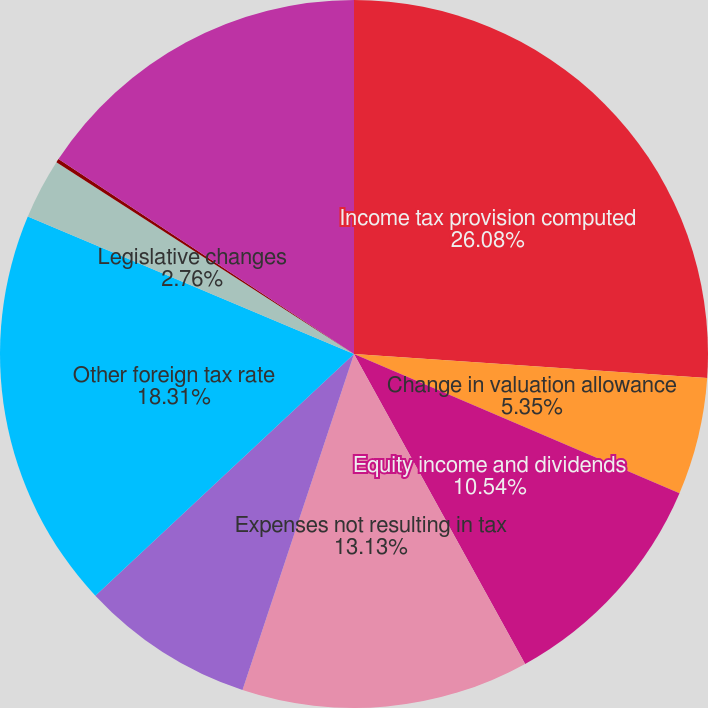Convert chart to OTSL. <chart><loc_0><loc_0><loc_500><loc_500><pie_chart><fcel>Income tax provision computed<fcel>Change in valuation allowance<fcel>Equity income and dividends<fcel>Expenses not resulting in tax<fcel>US tax effect of foreign<fcel>Other foreign tax rate<fcel>Legislative changes<fcel>State income taxes and other<fcel>Income tax provision (benefit)<nl><fcel>26.08%<fcel>5.35%<fcel>10.54%<fcel>13.13%<fcel>7.94%<fcel>18.31%<fcel>2.76%<fcel>0.17%<fcel>15.72%<nl></chart> 